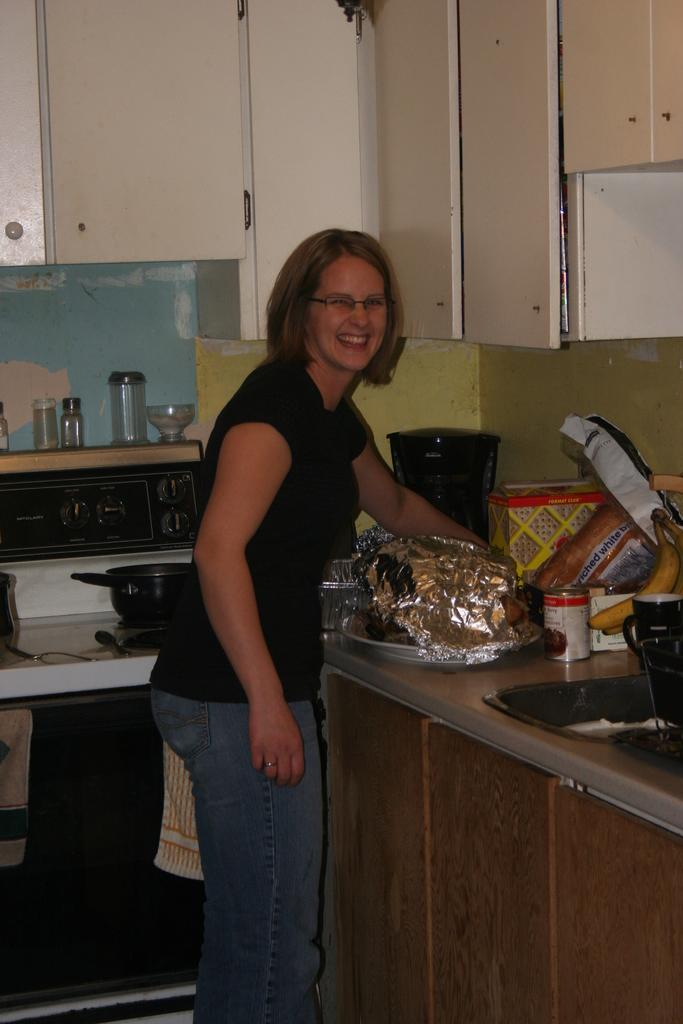<image>
Create a compact narrative representing the image presented. a lady stands next to a box that says format on it 